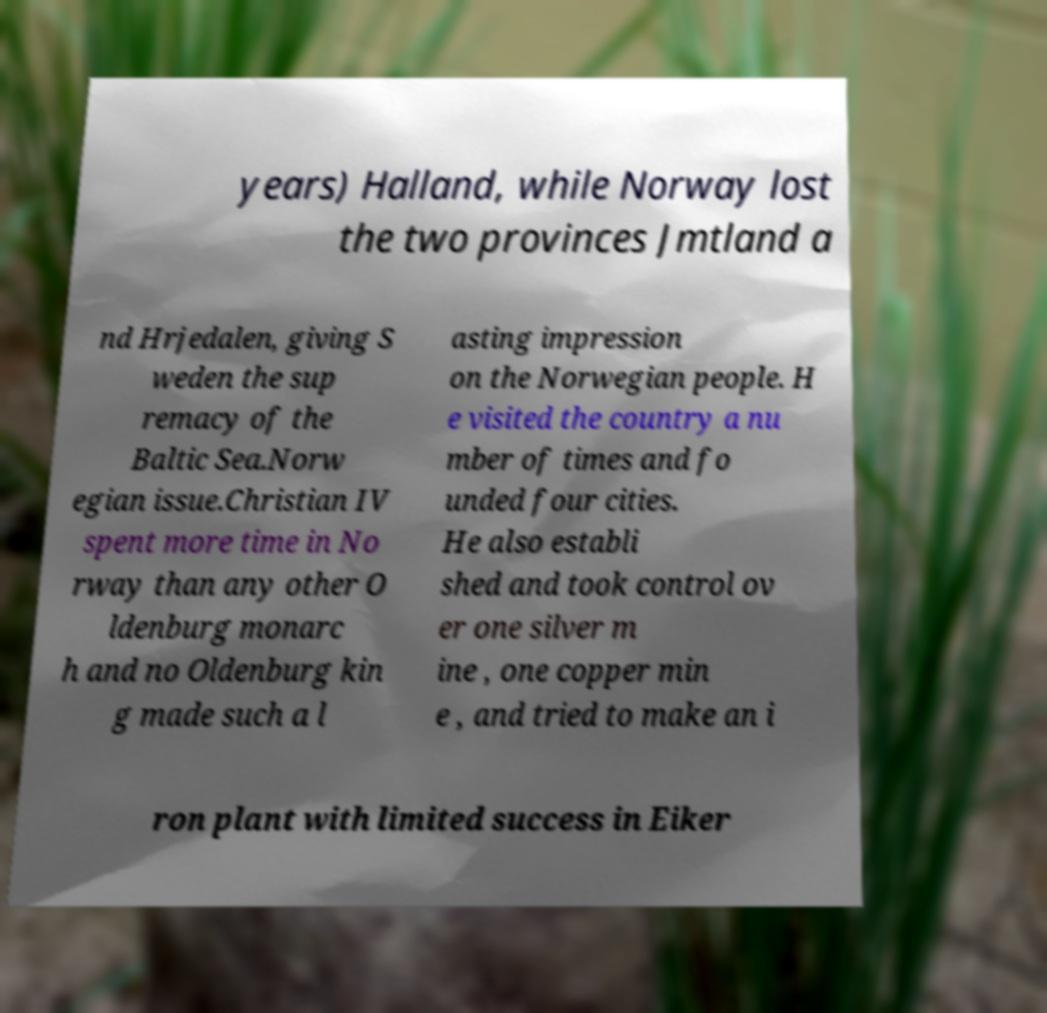For documentation purposes, I need the text within this image transcribed. Could you provide that? years) Halland, while Norway lost the two provinces Jmtland a nd Hrjedalen, giving S weden the sup remacy of the Baltic Sea.Norw egian issue.Christian IV spent more time in No rway than any other O ldenburg monarc h and no Oldenburg kin g made such a l asting impression on the Norwegian people. H e visited the country a nu mber of times and fo unded four cities. He also establi shed and took control ov er one silver m ine , one copper min e , and tried to make an i ron plant with limited success in Eiker 